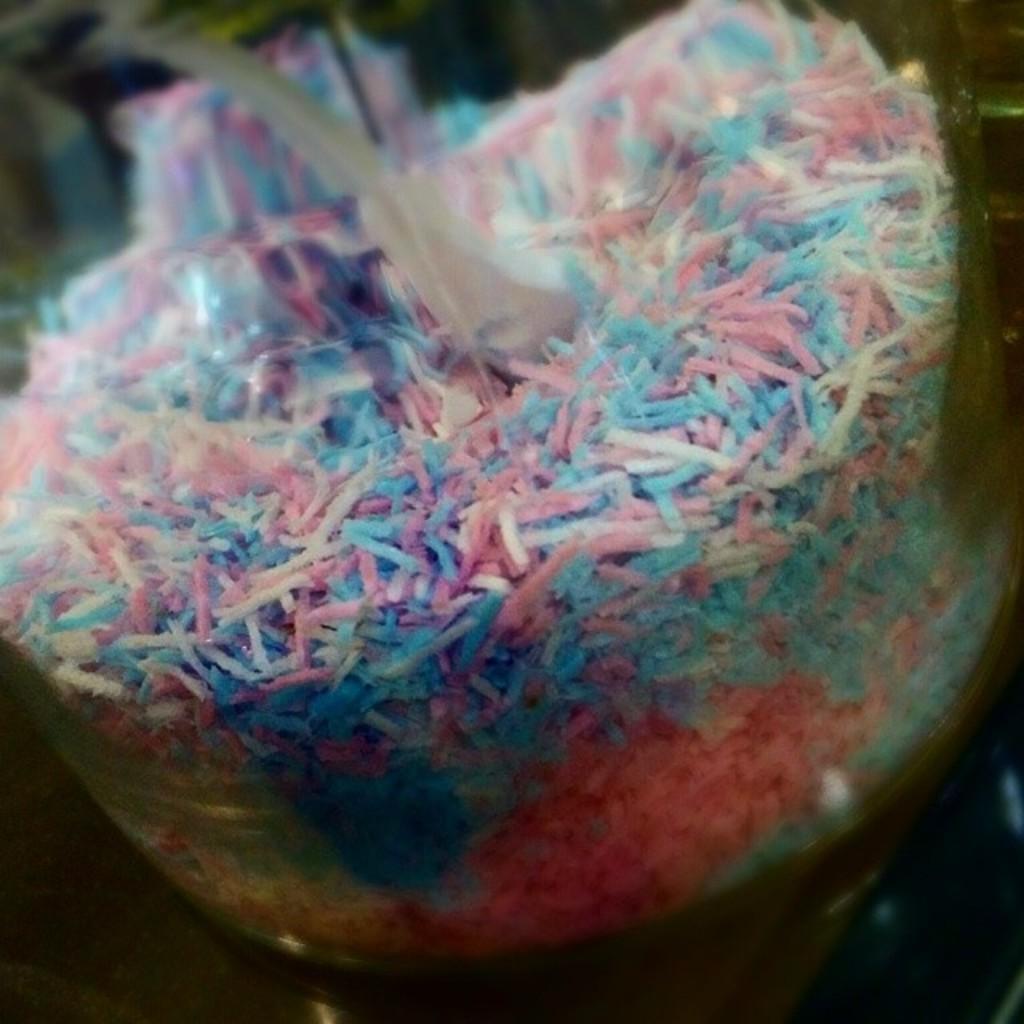Please provide a concise description of this image. The picture consist of candy in a glass jar. 